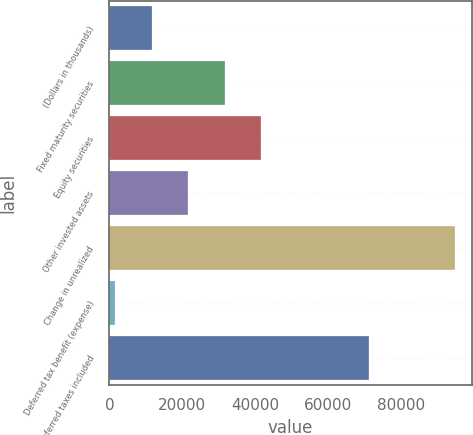<chart> <loc_0><loc_0><loc_500><loc_500><bar_chart><fcel>(Dollars in thousands)<fcel>Fixed maturity securities<fcel>Equity securities<fcel>Other invested assets<fcel>Change in unrealized<fcel>Deferred tax benefit (expense)<fcel>net of deferred taxes included<nl><fcel>11623.2<fcel>31693.6<fcel>41728.8<fcel>21658.4<fcel>94791<fcel>1588<fcel>71298<nl></chart> 